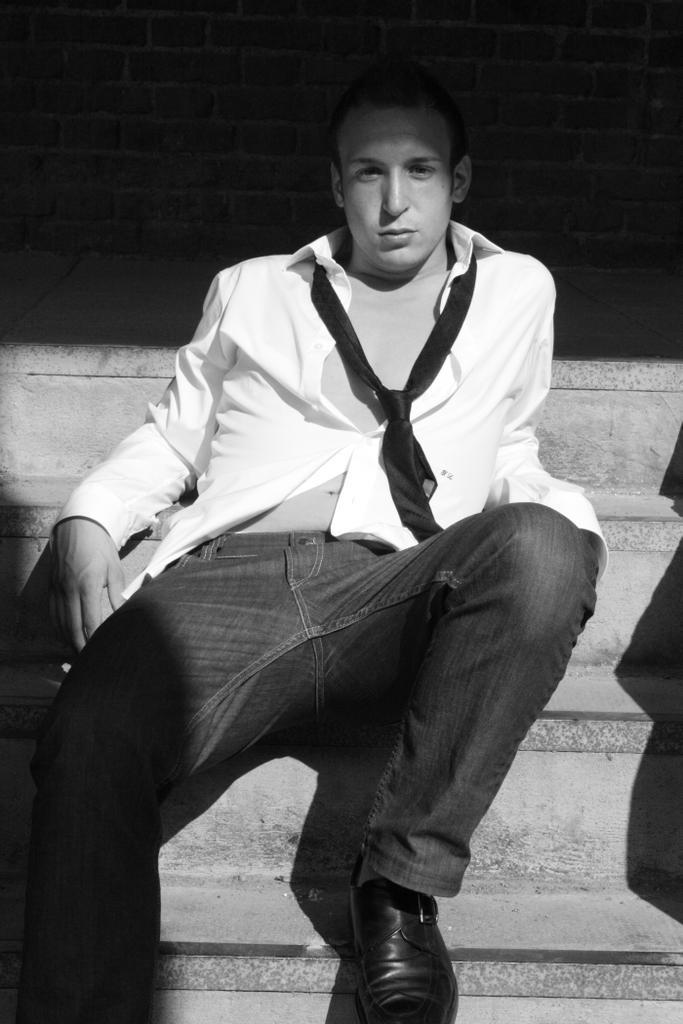How would you summarize this image in a sentence or two? In this image I can see the person sitting on the stairs and the image is in black and white. 